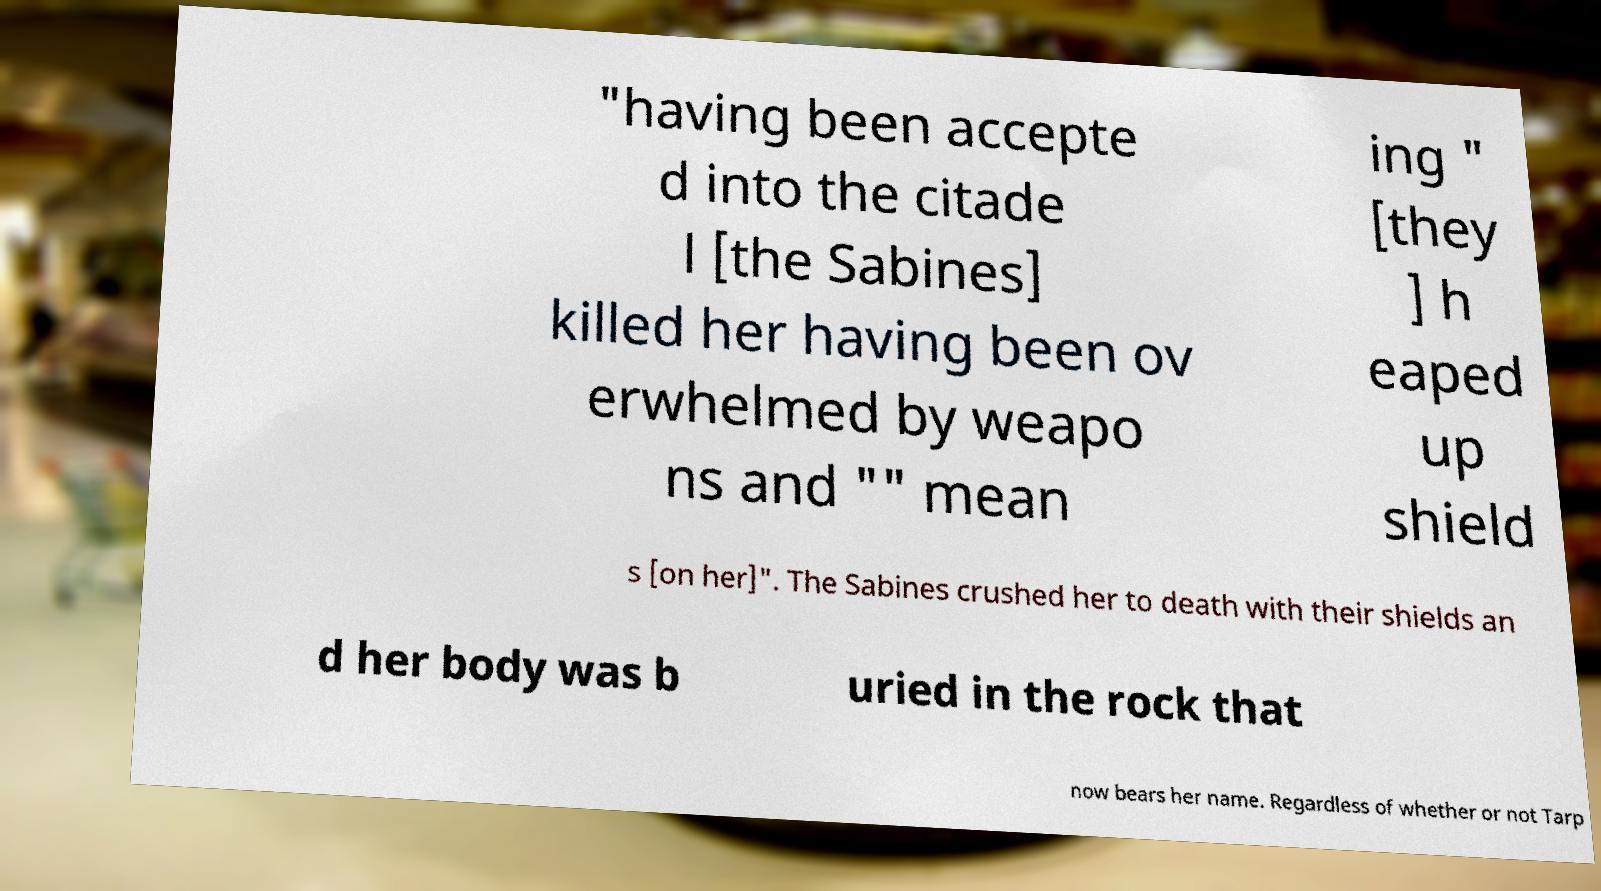Please read and relay the text visible in this image. What does it say? "having been accepte d into the citade l [the Sabines] killed her having been ov erwhelmed by weapo ns and "" mean ing " [they ] h eaped up shield s [on her]". The Sabines crushed her to death with their shields an d her body was b uried in the rock that now bears her name. Regardless of whether or not Tarp 